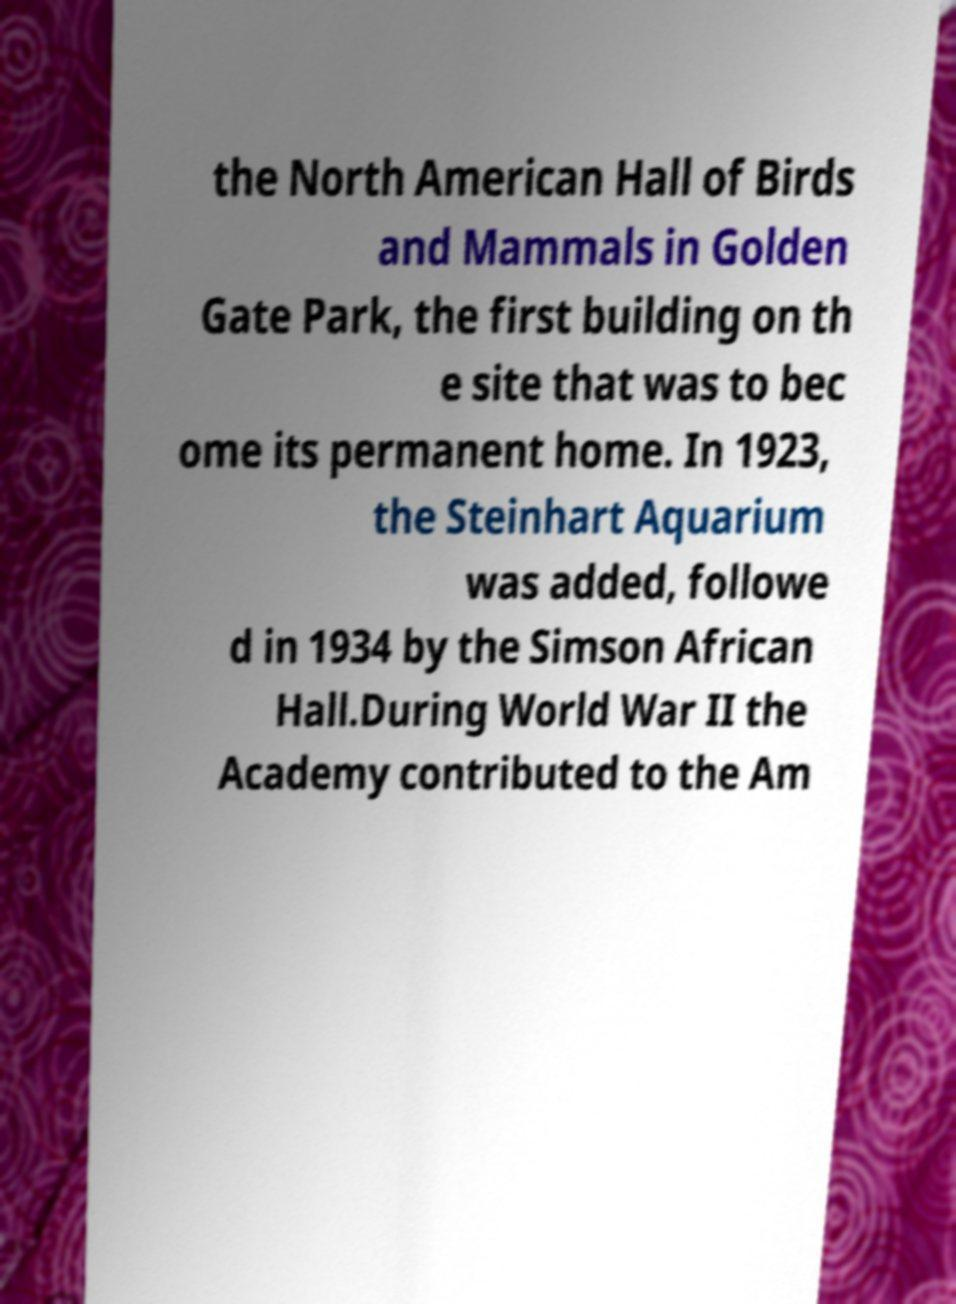Can you read and provide the text displayed in the image?This photo seems to have some interesting text. Can you extract and type it out for me? the North American Hall of Birds and Mammals in Golden Gate Park, the first building on th e site that was to bec ome its permanent home. In 1923, the Steinhart Aquarium was added, followe d in 1934 by the Simson African Hall.During World War II the Academy contributed to the Am 